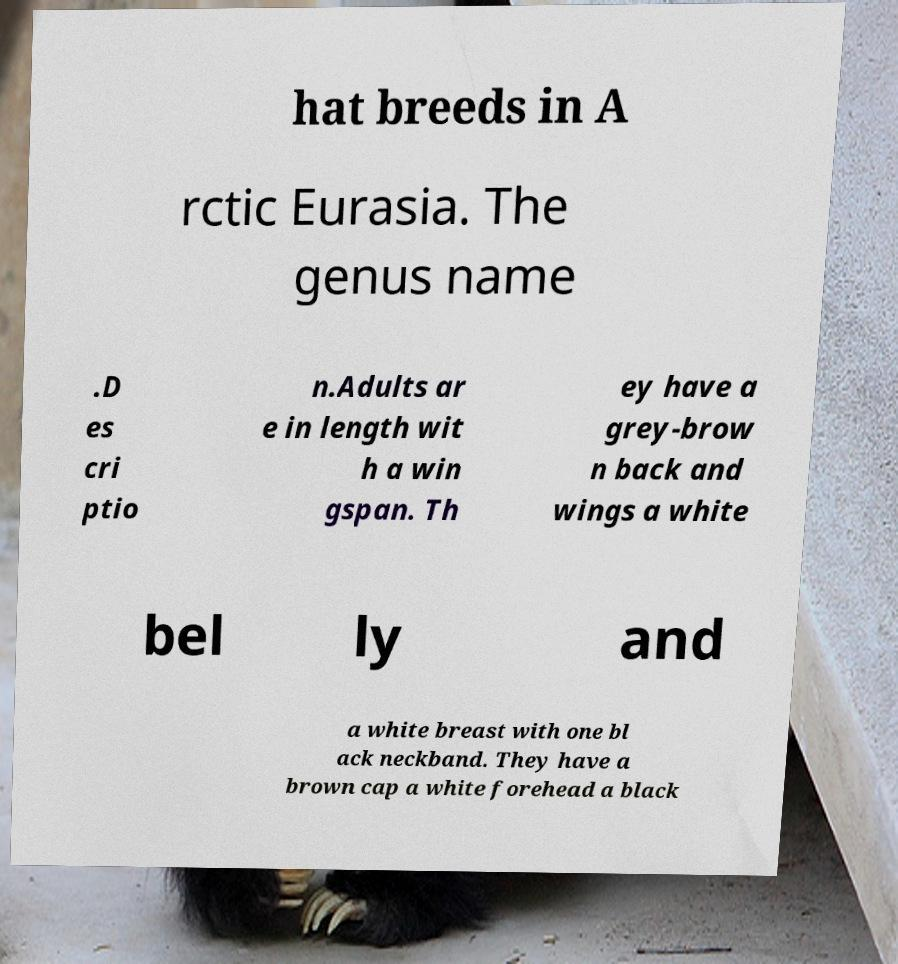Please read and relay the text visible in this image. What does it say? hat breeds in A rctic Eurasia. The genus name .D es cri ptio n.Adults ar e in length wit h a win gspan. Th ey have a grey-brow n back and wings a white bel ly and a white breast with one bl ack neckband. They have a brown cap a white forehead a black 